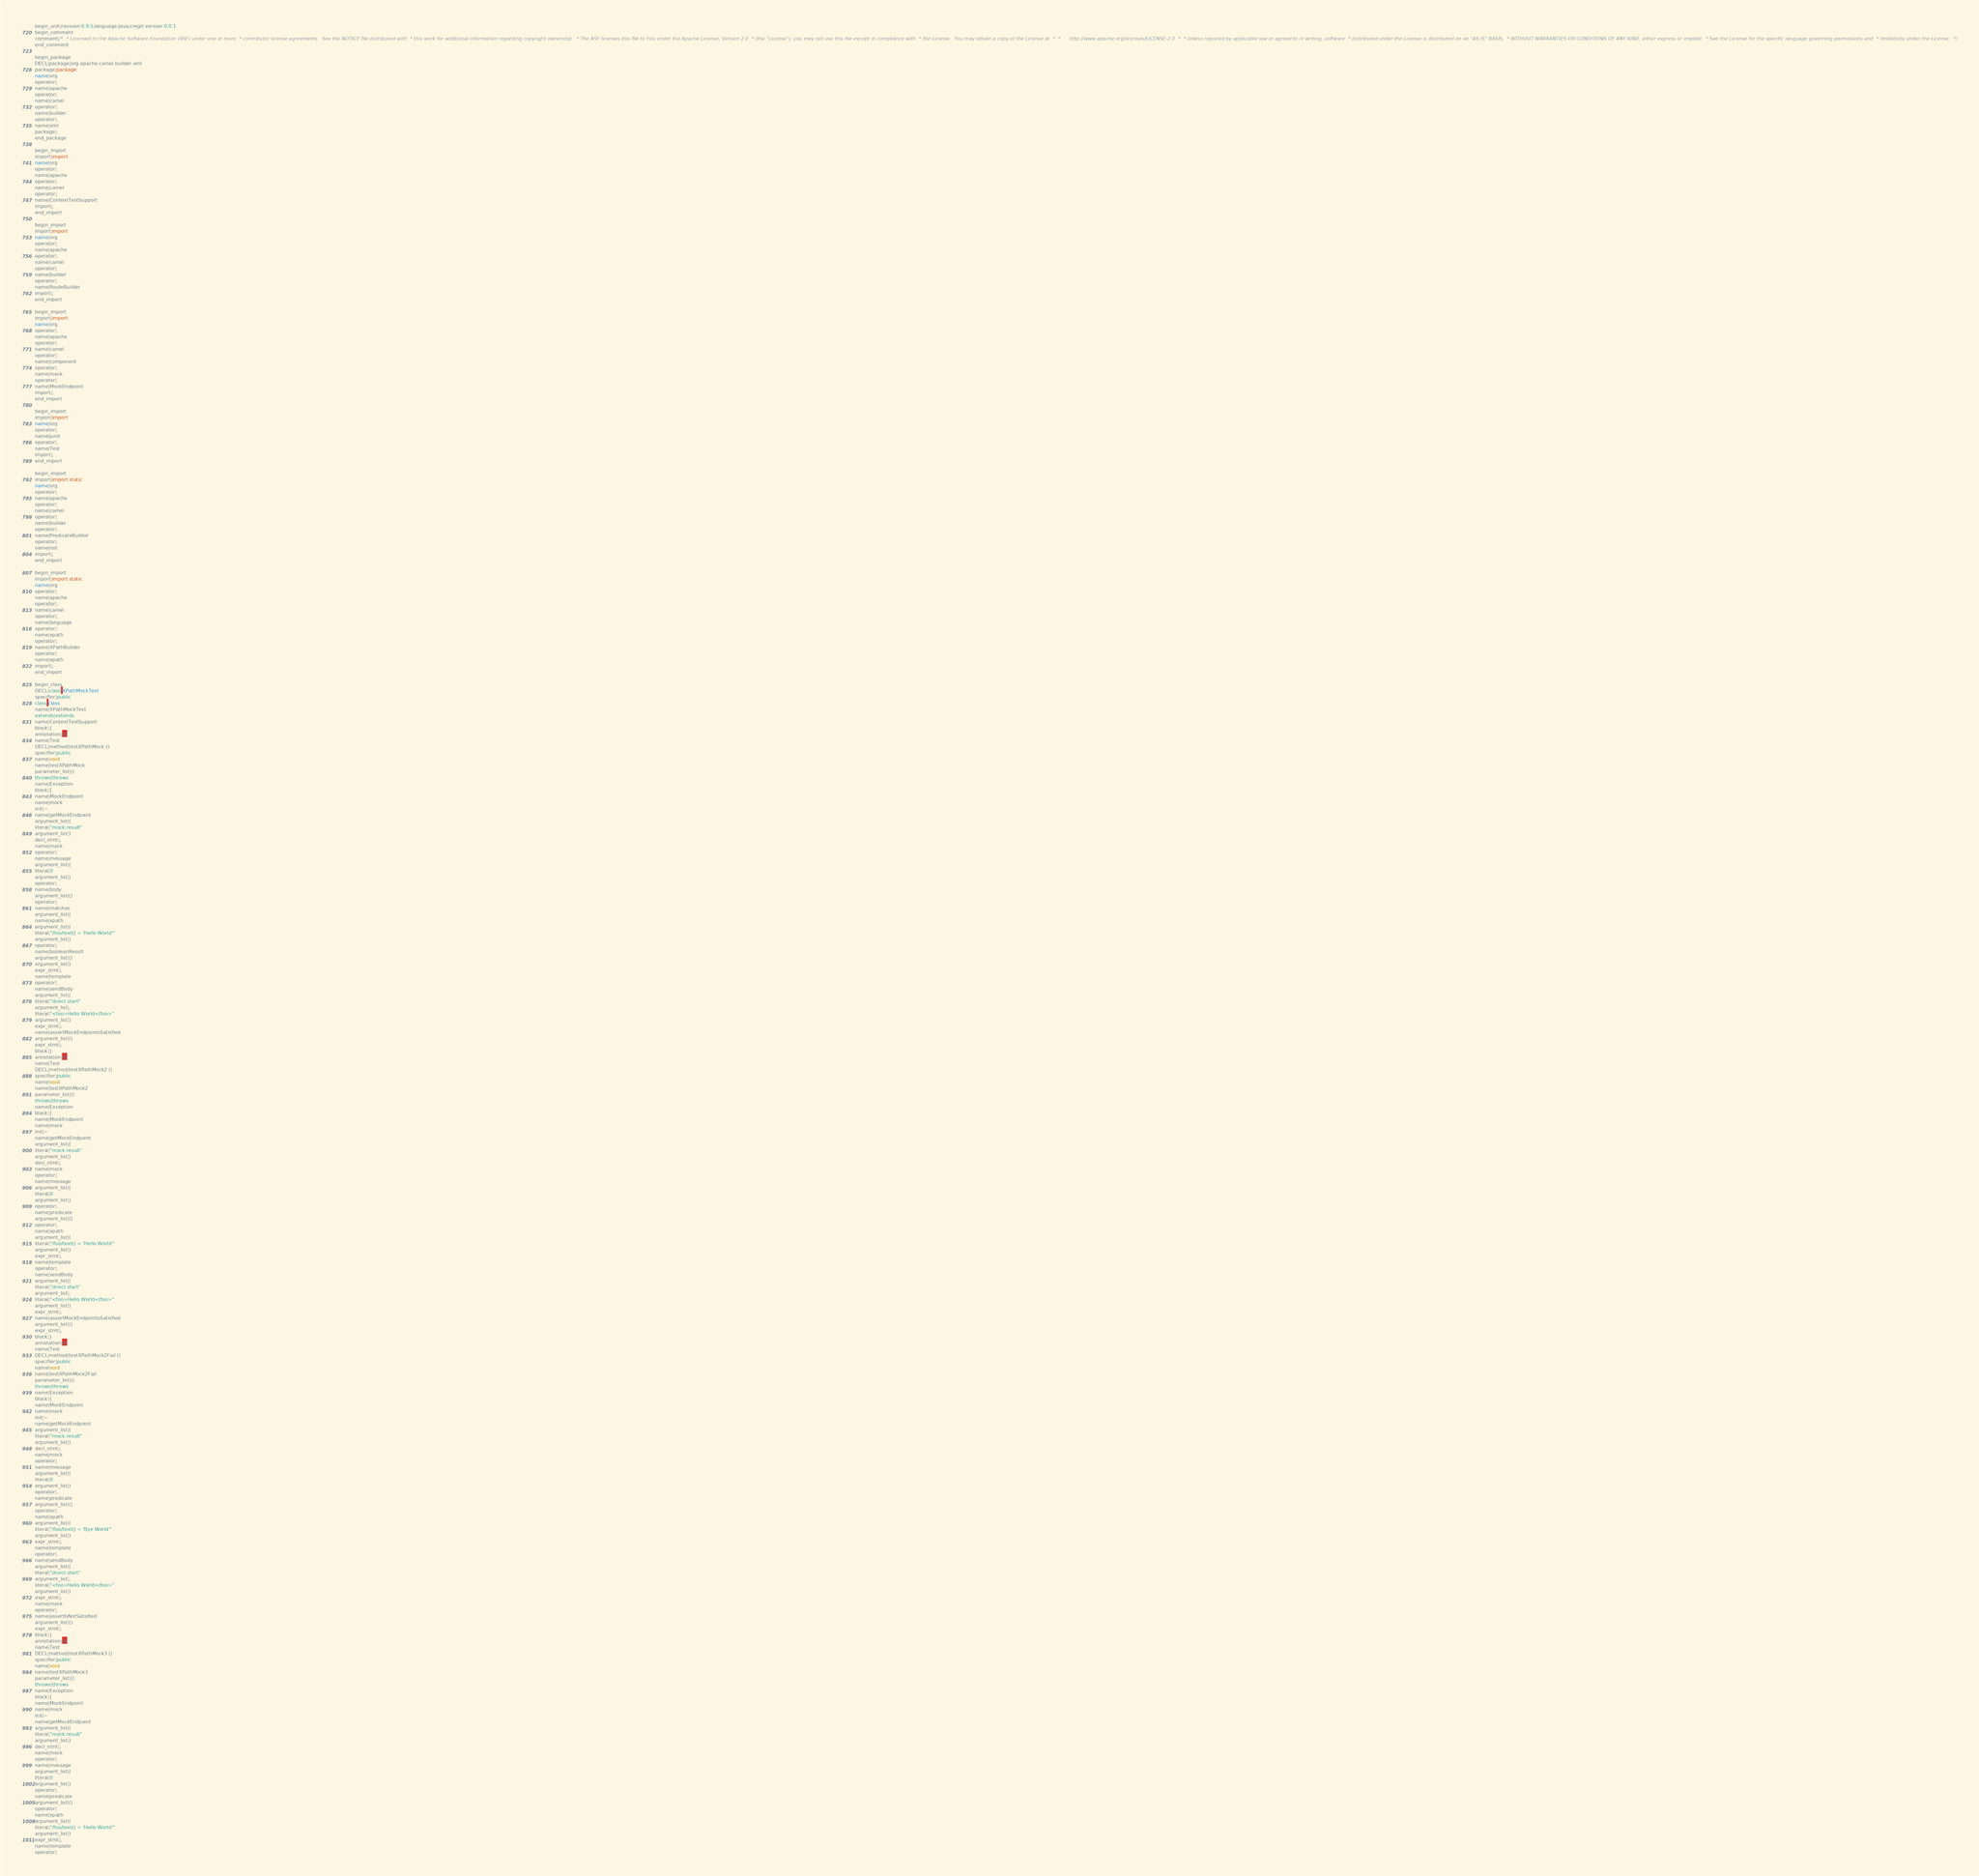Convert code to text. <code><loc_0><loc_0><loc_500><loc_500><_Java_>begin_unit|revision:0.9.5;language:Java;cregit-version:0.0.1
begin_comment
comment|/*  * Licensed to the Apache Software Foundation (ASF) under one or more  * contributor license agreements.  See the NOTICE file distributed with  * this work for additional information regarding copyright ownership.  * The ASF licenses this file to You under the Apache License, Version 2.0  * (the "License"); you may not use this file except in compliance with  * the License.  You may obtain a copy of the License at  *  *      http://www.apache.org/licenses/LICENSE-2.0  *  * Unless required by applicable law or agreed to in writing, software  * distributed under the License is distributed on an "AS IS" BASIS,  * WITHOUT WARRANTIES OR CONDITIONS OF ANY KIND, either express or implied.  * See the License for the specific language governing permissions and  * limitations under the License.  */
end_comment

begin_package
DECL|package|org.apache.camel.builder.xml
package|package
name|org
operator|.
name|apache
operator|.
name|camel
operator|.
name|builder
operator|.
name|xml
package|;
end_package

begin_import
import|import
name|org
operator|.
name|apache
operator|.
name|camel
operator|.
name|ContextTestSupport
import|;
end_import

begin_import
import|import
name|org
operator|.
name|apache
operator|.
name|camel
operator|.
name|builder
operator|.
name|RouteBuilder
import|;
end_import

begin_import
import|import
name|org
operator|.
name|apache
operator|.
name|camel
operator|.
name|component
operator|.
name|mock
operator|.
name|MockEndpoint
import|;
end_import

begin_import
import|import
name|org
operator|.
name|junit
operator|.
name|Test
import|;
end_import

begin_import
import|import static
name|org
operator|.
name|apache
operator|.
name|camel
operator|.
name|builder
operator|.
name|PredicateBuilder
operator|.
name|not
import|;
end_import

begin_import
import|import static
name|org
operator|.
name|apache
operator|.
name|camel
operator|.
name|language
operator|.
name|xpath
operator|.
name|XPathBuilder
operator|.
name|xpath
import|;
end_import

begin_class
DECL|class|XPathMockTest
specifier|public
class|class
name|XPathMockTest
extends|extends
name|ContextTestSupport
block|{
annotation|@
name|Test
DECL|method|testXPathMock ()
specifier|public
name|void
name|testXPathMock
parameter_list|()
throws|throws
name|Exception
block|{
name|MockEndpoint
name|mock
init|=
name|getMockEndpoint
argument_list|(
literal|"mock:result"
argument_list|)
decl_stmt|;
name|mock
operator|.
name|message
argument_list|(
literal|0
argument_list|)
operator|.
name|body
argument_list|()
operator|.
name|matches
argument_list|(
name|xpath
argument_list|(
literal|"/foo/text() = 'Hello World'"
argument_list|)
operator|.
name|booleanResult
argument_list|()
argument_list|)
expr_stmt|;
name|template
operator|.
name|sendBody
argument_list|(
literal|"direct:start"
argument_list|,
literal|"<foo>Hello World</foo>"
argument_list|)
expr_stmt|;
name|assertMockEndpointsSatisfied
argument_list|()
expr_stmt|;
block|}
annotation|@
name|Test
DECL|method|testXPathMock2 ()
specifier|public
name|void
name|testXPathMock2
parameter_list|()
throws|throws
name|Exception
block|{
name|MockEndpoint
name|mock
init|=
name|getMockEndpoint
argument_list|(
literal|"mock:result"
argument_list|)
decl_stmt|;
name|mock
operator|.
name|message
argument_list|(
literal|0
argument_list|)
operator|.
name|predicate
argument_list|()
operator|.
name|xpath
argument_list|(
literal|"/foo/text() = 'Hello World'"
argument_list|)
expr_stmt|;
name|template
operator|.
name|sendBody
argument_list|(
literal|"direct:start"
argument_list|,
literal|"<foo>Hello World</foo>"
argument_list|)
expr_stmt|;
name|assertMockEndpointsSatisfied
argument_list|()
expr_stmt|;
block|}
annotation|@
name|Test
DECL|method|testXPathMock2Fail ()
specifier|public
name|void
name|testXPathMock2Fail
parameter_list|()
throws|throws
name|Exception
block|{
name|MockEndpoint
name|mock
init|=
name|getMockEndpoint
argument_list|(
literal|"mock:result"
argument_list|)
decl_stmt|;
name|mock
operator|.
name|message
argument_list|(
literal|0
argument_list|)
operator|.
name|predicate
argument_list|()
operator|.
name|xpath
argument_list|(
literal|"/foo/text() = 'Bye World'"
argument_list|)
expr_stmt|;
name|template
operator|.
name|sendBody
argument_list|(
literal|"direct:start"
argument_list|,
literal|"<foo>Hello World</foo>"
argument_list|)
expr_stmt|;
name|mock
operator|.
name|assertIsNotSatisfied
argument_list|()
expr_stmt|;
block|}
annotation|@
name|Test
DECL|method|testXPathMock3 ()
specifier|public
name|void
name|testXPathMock3
parameter_list|()
throws|throws
name|Exception
block|{
name|MockEndpoint
name|mock
init|=
name|getMockEndpoint
argument_list|(
literal|"mock:result"
argument_list|)
decl_stmt|;
name|mock
operator|.
name|message
argument_list|(
literal|0
argument_list|)
operator|.
name|predicate
argument_list|()
operator|.
name|xpath
argument_list|(
literal|"/foo/text() = 'Hello World'"
argument_list|)
expr_stmt|;
name|template
operator|.</code> 